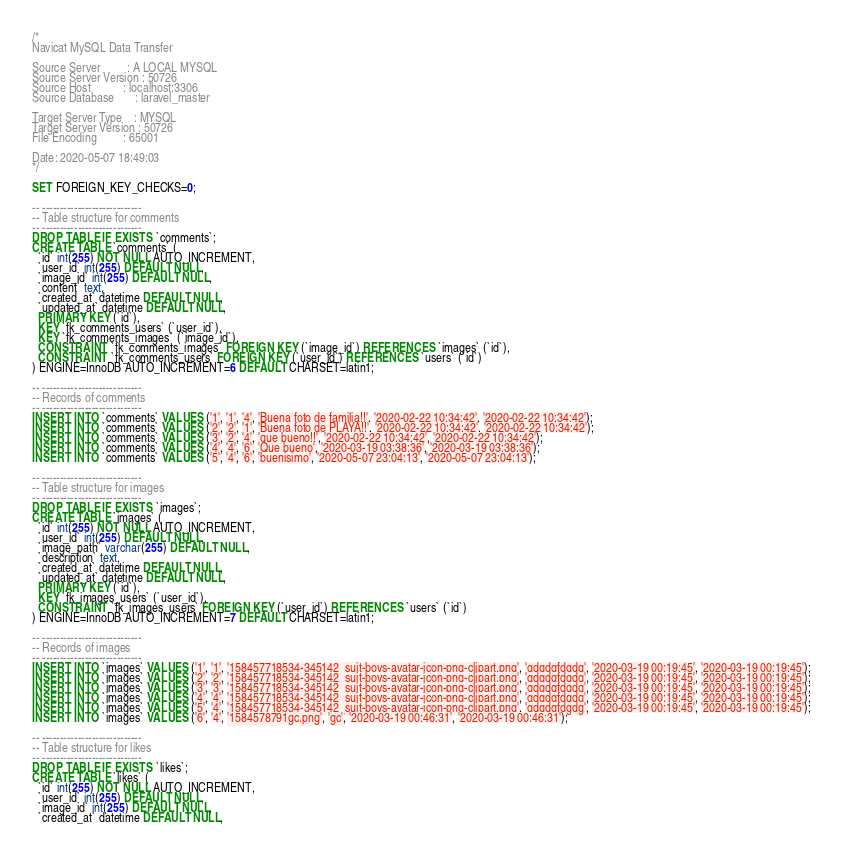Convert code to text. <code><loc_0><loc_0><loc_500><loc_500><_SQL_>/*
Navicat MySQL Data Transfer

Source Server         : A LOCAL MYSQL
Source Server Version : 50726
Source Host           : localhost:3306
Source Database       : laravel_master

Target Server Type    : MYSQL
Target Server Version : 50726
File Encoding         : 65001

Date: 2020-05-07 18:49:03
*/

SET FOREIGN_KEY_CHECKS=0;

-- ----------------------------
-- Table structure for comments
-- ----------------------------
DROP TABLE IF EXISTS `comments`;
CREATE TABLE `comments` (
  `id` int(255) NOT NULL AUTO_INCREMENT,
  `user_id` int(255) DEFAULT NULL,
  `image_id` int(255) DEFAULT NULL,
  `content` text,
  `created_at` datetime DEFAULT NULL,
  `updated_at` datetime DEFAULT NULL,
  PRIMARY KEY (`id`),
  KEY `fk_comments_users` (`user_id`),
  KEY `fk_comments_images` (`image_id`),
  CONSTRAINT `fk_comments_images` FOREIGN KEY (`image_id`) REFERENCES `images` (`id`),
  CONSTRAINT `fk_comments_users` FOREIGN KEY (`user_id`) REFERENCES `users` (`id`)
) ENGINE=InnoDB AUTO_INCREMENT=6 DEFAULT CHARSET=latin1;

-- ----------------------------
-- Records of comments
-- ----------------------------
INSERT INTO `comments` VALUES ('1', '1', '4', 'Buena foto de familia!!', '2020-02-22 10:34:42', '2020-02-22 10:34:42');
INSERT INTO `comments` VALUES ('2', '2', '1', 'Buena foto de PLAYA!!', '2020-02-22 10:34:42', '2020-02-22 10:34:42');
INSERT INTO `comments` VALUES ('3', '2', '4', 'que bueno!!', '2020-02-22 10:34:42', '2020-02-22 10:34:42');
INSERT INTO `comments` VALUES ('4', '4', '6', 'Que bueno', '2020-03-19 03:38:36', '2020-03-19 03:38:36');
INSERT INTO `comments` VALUES ('5', '4', '6', 'buenisimo', '2020-05-07 23:04:13', '2020-05-07 23:04:13');

-- ----------------------------
-- Table structure for images
-- ----------------------------
DROP TABLE IF EXISTS `images`;
CREATE TABLE `images` (
  `id` int(255) NOT NULL AUTO_INCREMENT,
  `user_id` int(255) DEFAULT NULL,
  `image_path` varchar(255) DEFAULT NULL,
  `description` text,
  `created_at` datetime DEFAULT NULL,
  `updated_at` datetime DEFAULT NULL,
  PRIMARY KEY (`id`),
  KEY `fk_images_users` (`user_id`),
  CONSTRAINT `fk_images_users` FOREIGN KEY (`user_id`) REFERENCES `users` (`id`)
) ENGINE=InnoDB AUTO_INCREMENT=7 DEFAULT CHARSET=latin1;

-- ----------------------------
-- Records of images
-- ----------------------------
INSERT INTO `images` VALUES ('1', '1', '158457718534-345142_suit-boys-avatar-icon-png-clipart.png', 'gdgdgfdgdg', '2020-03-19 00:19:45', '2020-03-19 00:19:45');
INSERT INTO `images` VALUES ('2', '2', '158457718534-345142_suit-boys-avatar-icon-png-clipart.png', 'gdgdgfdgdg', '2020-03-19 00:19:45', '2020-03-19 00:19:45');
INSERT INTO `images` VALUES ('3', '3', '158457718534-345142_suit-boys-avatar-icon-png-clipart.png', 'gdgdgfdgdg', '2020-03-19 00:19:45', '2020-03-19 00:19:45');
INSERT INTO `images` VALUES ('4', '4', '158457718534-345142_suit-boys-avatar-icon-png-clipart.png', 'gdgdgfdgdg', '2020-03-19 00:19:45', '2020-03-19 00:19:45');
INSERT INTO `images` VALUES ('5', '4', '158457718534-345142_suit-boys-avatar-icon-png-clipart.png', 'gdgdgfdgdg', '2020-03-19 00:19:45', '2020-03-19 00:19:45');
INSERT INTO `images` VALUES ('6', '4', '1584578791gc.png', 'gc', '2020-03-19 00:46:31', '2020-03-19 00:46:31');

-- ----------------------------
-- Table structure for likes
-- ----------------------------
DROP TABLE IF EXISTS `likes`;
CREATE TABLE `likes` (
  `id` int(255) NOT NULL AUTO_INCREMENT,
  `user_id` int(255) DEFAULT NULL,
  `image_id` int(255) DEFAULT NULL,
  `created_at` datetime DEFAULT NULL,</code> 